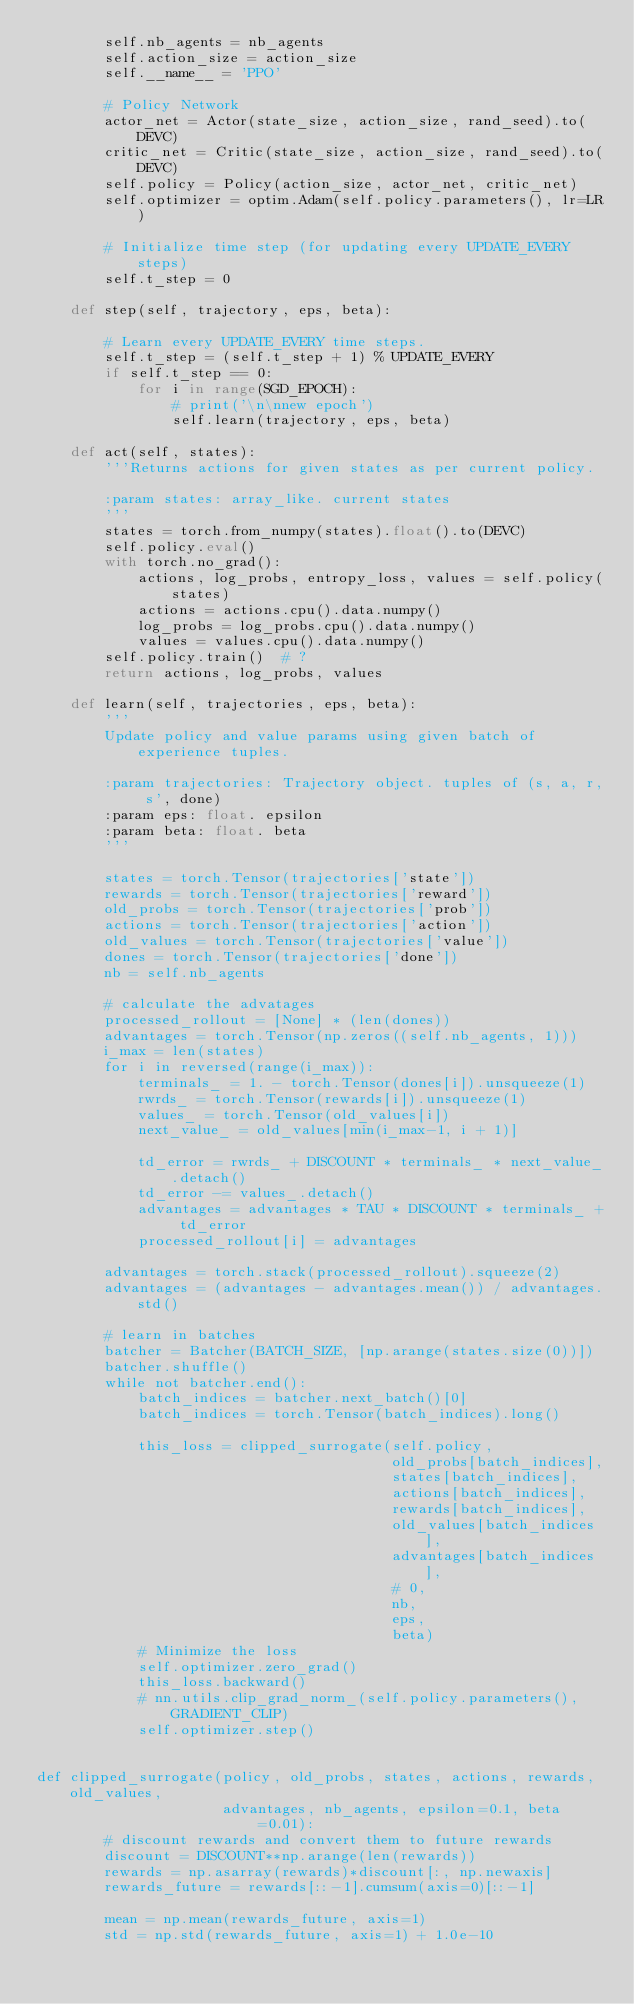<code> <loc_0><loc_0><loc_500><loc_500><_Python_>        self.nb_agents = nb_agents
        self.action_size = action_size
        self.__name__ = 'PPO'

        # Policy Network
        actor_net = Actor(state_size, action_size, rand_seed).to(DEVC)
        critic_net = Critic(state_size, action_size, rand_seed).to(DEVC)
        self.policy = Policy(action_size, actor_net, critic_net)
        self.optimizer = optim.Adam(self.policy.parameters(), lr=LR)

        # Initialize time step (for updating every UPDATE_EVERY steps)
        self.t_step = 0

    def step(self, trajectory, eps, beta):

        # Learn every UPDATE_EVERY time steps.
        self.t_step = (self.t_step + 1) % UPDATE_EVERY
        if self.t_step == 0:
            for i in range(SGD_EPOCH):
                # print('\n\nnew epoch')
                self.learn(trajectory, eps, beta)

    def act(self, states):
        '''Returns actions for given states as per current policy.

        :param states: array_like. current states
        '''
        states = torch.from_numpy(states).float().to(DEVC)
        self.policy.eval()
        with torch.no_grad():
            actions, log_probs, entropy_loss, values = self.policy(states)
            actions = actions.cpu().data.numpy()
            log_probs = log_probs.cpu().data.numpy()
            values = values.cpu().data.numpy()
        self.policy.train()  # ?
        return actions, log_probs, values

    def learn(self, trajectories, eps, beta):
        '''
        Update policy and value params using given batch of experience tuples.

        :param trajectories: Trajectory object. tuples of (s, a, r, s', done)
        :param eps: float. epsilon
        :param beta: float. beta
        '''

        states = torch.Tensor(trajectories['state'])
        rewards = torch.Tensor(trajectories['reward'])
        old_probs = torch.Tensor(trajectories['prob'])
        actions = torch.Tensor(trajectories['action'])
        old_values = torch.Tensor(trajectories['value'])
        dones = torch.Tensor(trajectories['done'])
        nb = self.nb_agents

        # calculate the advatages
        processed_rollout = [None] * (len(dones))
        advantages = torch.Tensor(np.zeros((self.nb_agents, 1)))
        i_max = len(states)
        for i in reversed(range(i_max)):
            terminals_ = 1. - torch.Tensor(dones[i]).unsqueeze(1)
            rwrds_ = torch.Tensor(rewards[i]).unsqueeze(1)
            values_ = torch.Tensor(old_values[i])
            next_value_ = old_values[min(i_max-1, i + 1)]

            td_error = rwrds_ + DISCOUNT * terminals_ * next_value_.detach()
            td_error -= values_.detach()
            advantages = advantages * TAU * DISCOUNT * terminals_ + td_error
            processed_rollout[i] = advantages

        advantages = torch.stack(processed_rollout).squeeze(2)
        advantages = (advantages - advantages.mean()) / advantages.std()

        # learn in batches
        batcher = Batcher(BATCH_SIZE, [np.arange(states.size(0))])
        batcher.shuffle()
        while not batcher.end():
            batch_indices = batcher.next_batch()[0]
            batch_indices = torch.Tensor(batch_indices).long()

            this_loss = clipped_surrogate(self.policy,
                                          old_probs[batch_indices],
                                          states[batch_indices],
                                          actions[batch_indices],
                                          rewards[batch_indices],
                                          old_values[batch_indices],
                                          advantages[batch_indices],
                                          # 0,
                                          nb,
                                          eps,
                                          beta)
            # Minimize the loss
            self.optimizer.zero_grad()
            this_loss.backward()
            # nn.utils.clip_grad_norm_(self.policy.parameters(), GRADIENT_CLIP)
            self.optimizer.step()


def clipped_surrogate(policy, old_probs, states, actions, rewards, old_values,
                      advantages, nb_agents, epsilon=0.1, beta=0.01):
        # discount rewards and convert them to future rewards
        discount = DISCOUNT**np.arange(len(rewards))
        rewards = np.asarray(rewards)*discount[:, np.newaxis]
        rewards_future = rewards[::-1].cumsum(axis=0)[::-1]

        mean = np.mean(rewards_future, axis=1)
        std = np.std(rewards_future, axis=1) + 1.0e-10</code> 